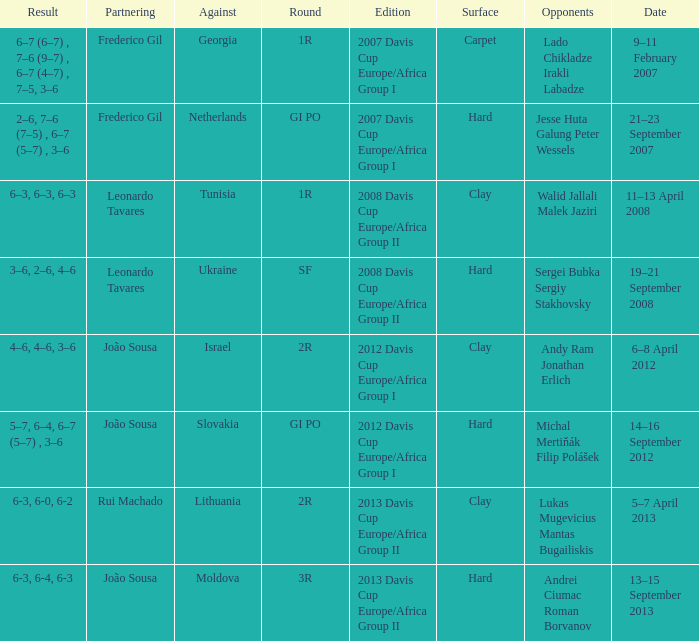What Edition had a Result of 6-3, 6-0, 6-2? 2013 Davis Cup Europe/Africa Group II. 